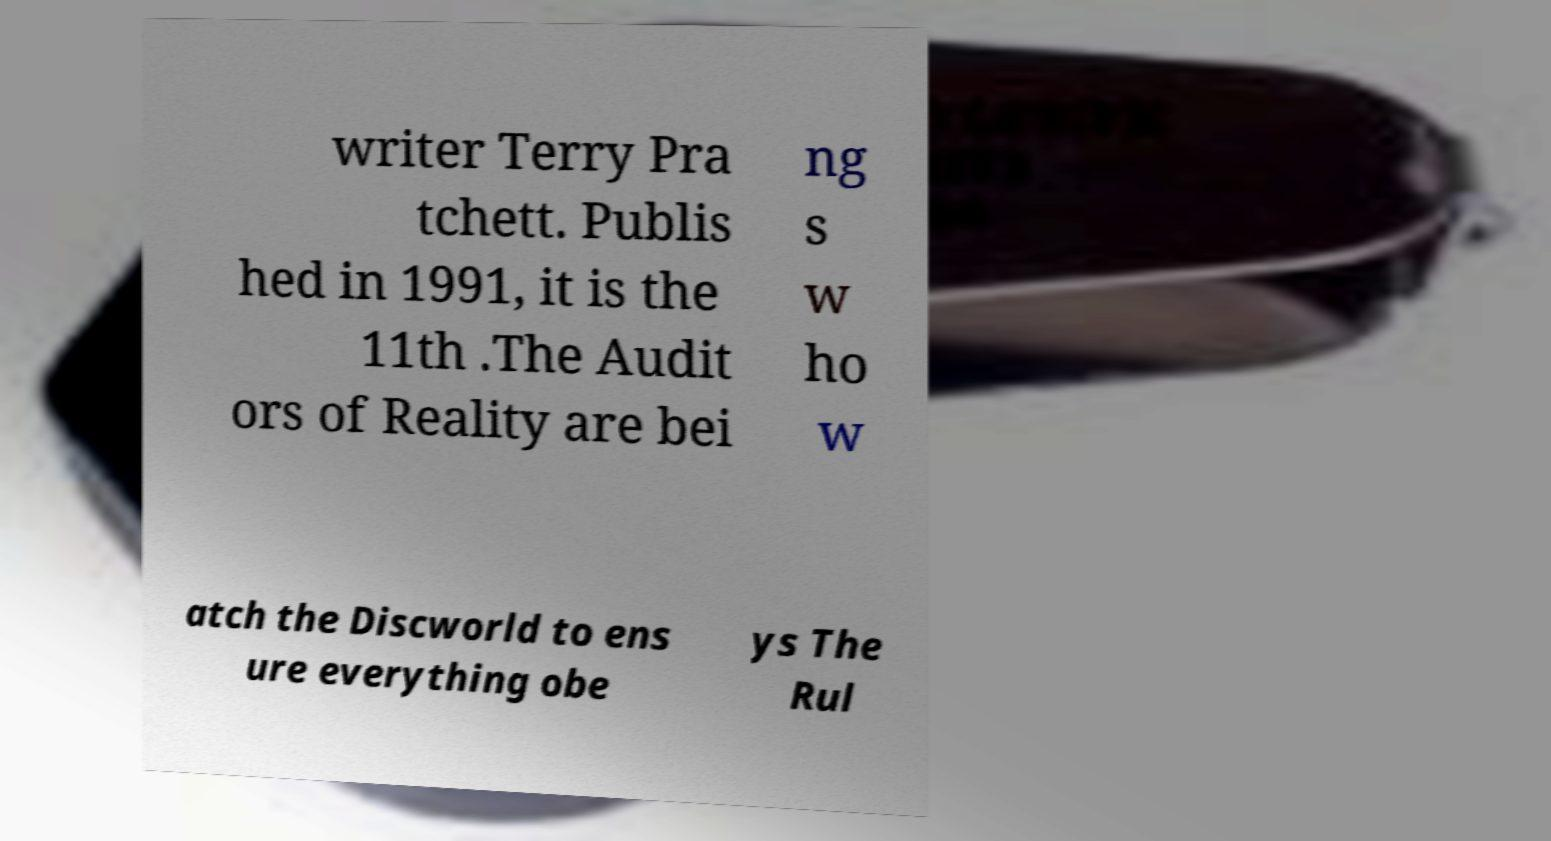Can you accurately transcribe the text from the provided image for me? writer Terry Pra tchett. Publis hed in 1991, it is the 11th .The Audit ors of Reality are bei ng s w ho w atch the Discworld to ens ure everything obe ys The Rul 